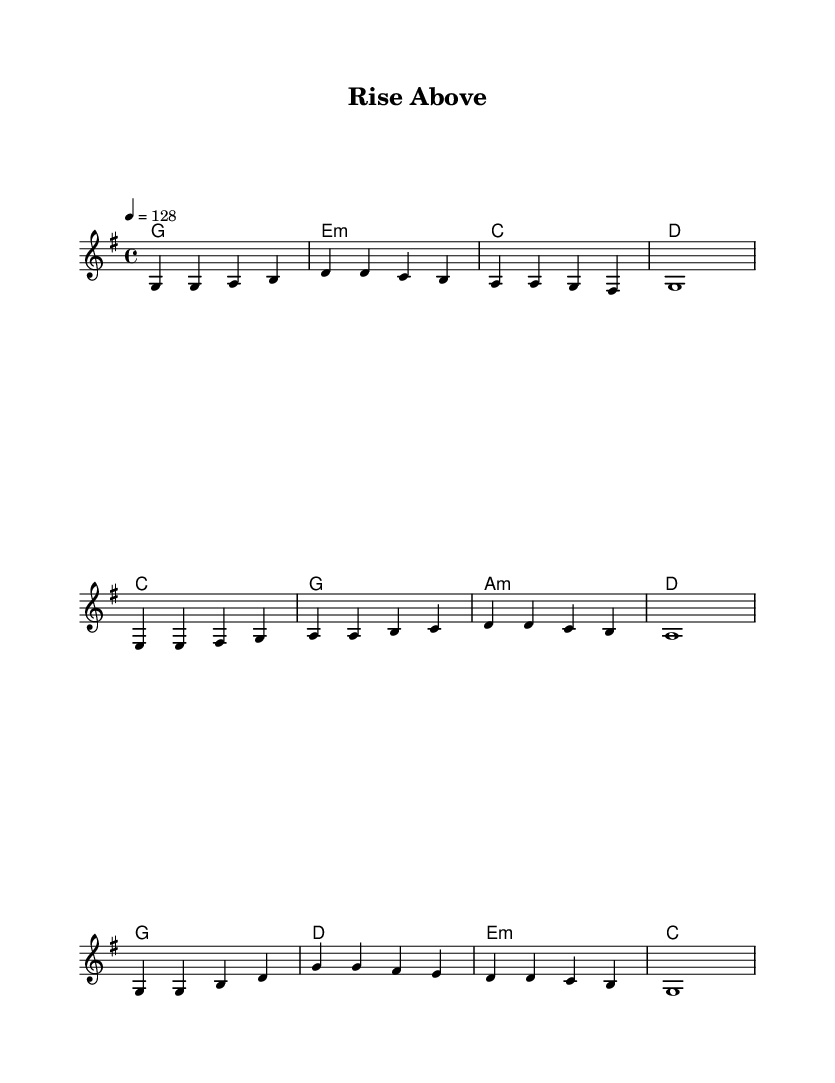What is the key signature of this music? The key signature is G major, which has one sharp (F#). This is indicated at the beginning of the sheet music right after the time signature.
Answer: G major What is the time signature of this music? The time signature is 4/4, meaning there are four beats in each measure and the quarter note gets one beat. This is shown at the beginning of the score.
Answer: 4/4 What is the tempo marking for this piece? The piece has a tempo marking of 128 beats per minute, indicated by the tempo directive that specifies the speed of the music.
Answer: 128 How many measures are in the chorus? The chorus consists of four measures, as counted from the music notation for that section which shows four distinct segments of notation.
Answer: 4 What is the main theme conveyed in the lyrics? The lyrics convey themes of problem-solving and overcoming challenges, emphasizing resilience and teamwork, which is a common theme in K-Pop for motivating listeners.
Answer: Problem-solving Which instrument is primarily used in this score? The primary instrument indicated in this score is a piano, as there is no specific instrument stated, but typically such a score is arranged for piano unless otherwise noted.
Answer: Piano What is the structure of the song? The structure consists of a verse, pre-chorus, and chorus, in a typical pop format where these elements are arranged sequentially to enhance the song’s dynamics.
Answer: Verse, Pre-Chorus, Chorus 